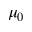Convert formula to latex. <formula><loc_0><loc_0><loc_500><loc_500>\mu _ { 0 }</formula> 